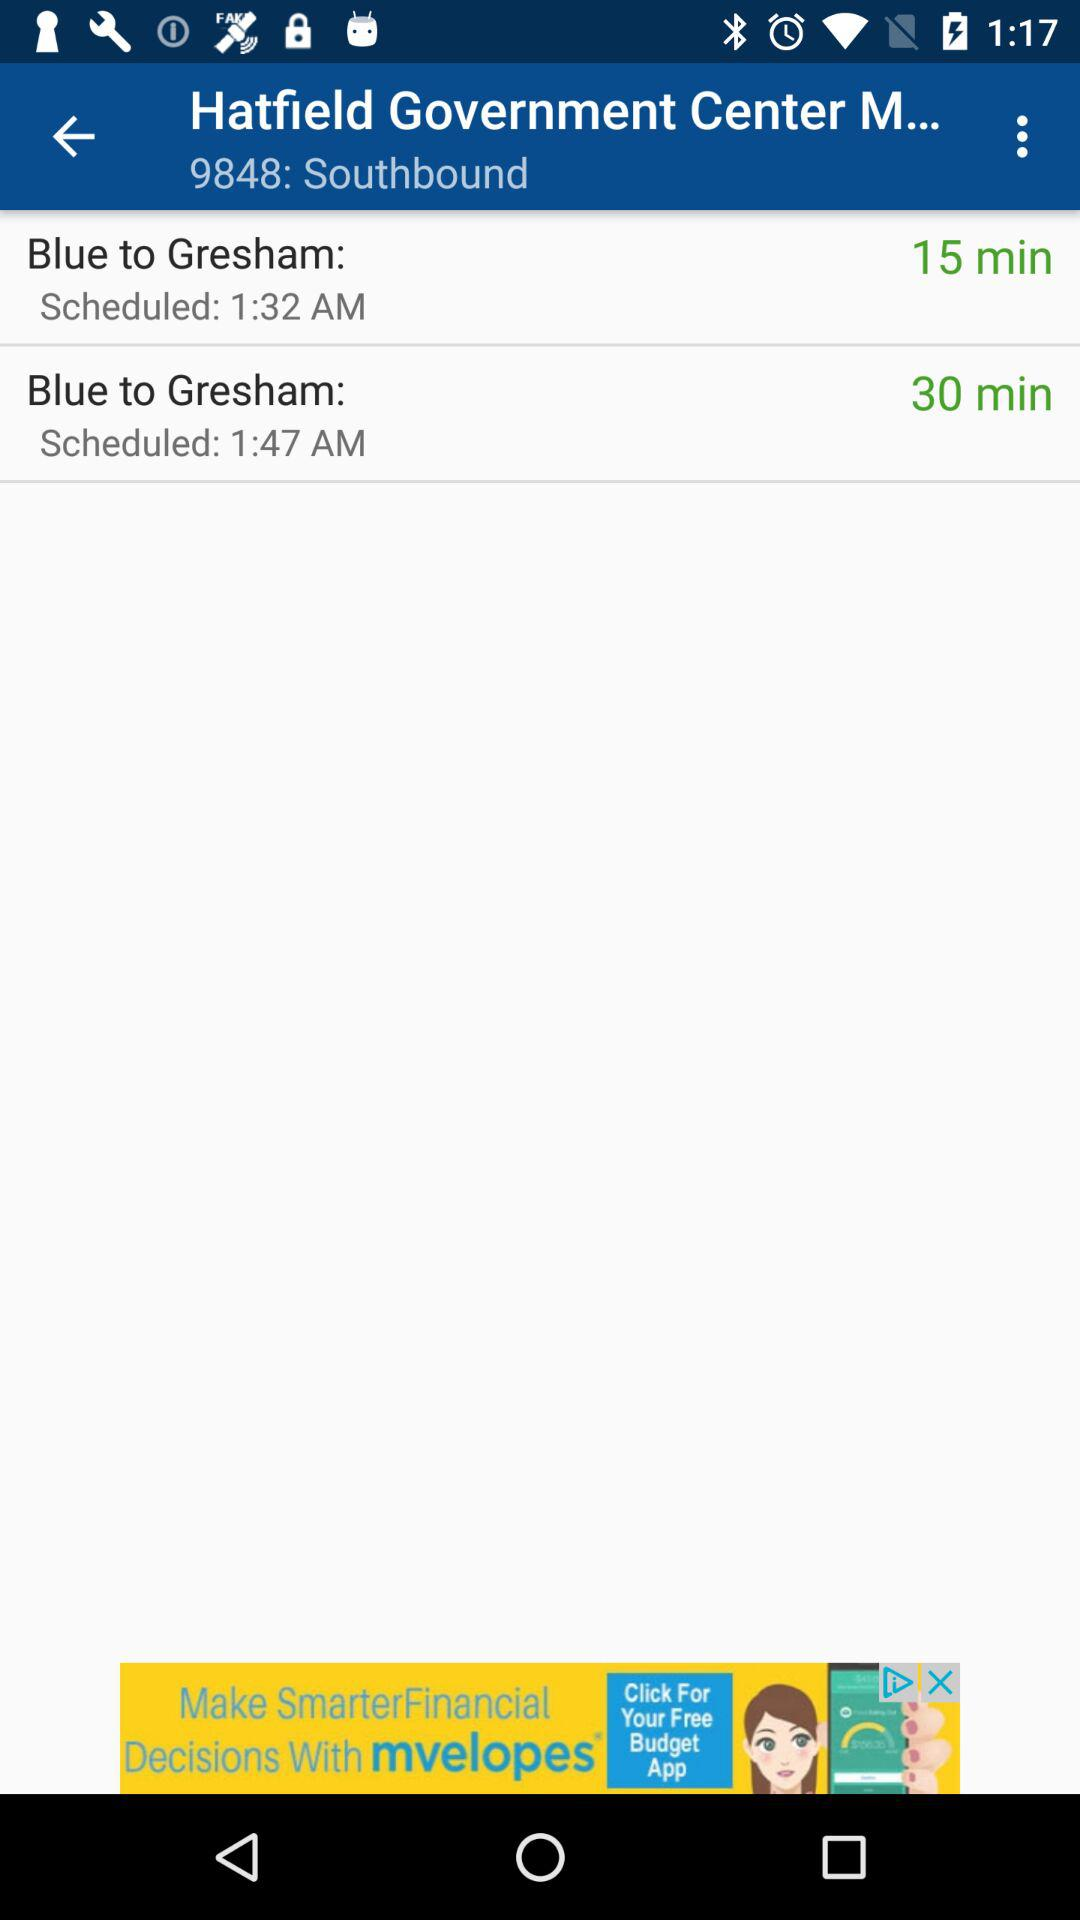What is the given number of southbound? The given number is 9848. 